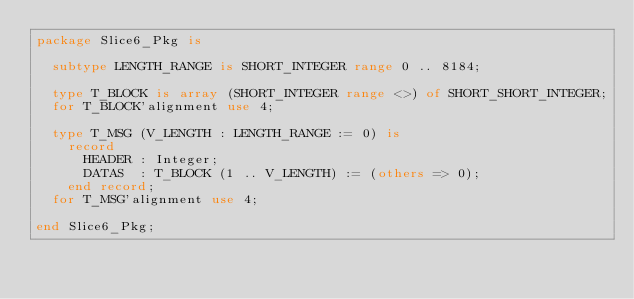<code> <loc_0><loc_0><loc_500><loc_500><_Ada_>package Slice6_Pkg is

  subtype LENGTH_RANGE is SHORT_INTEGER range 0 .. 8184;

  type T_BLOCK is array (SHORT_INTEGER range <>) of SHORT_SHORT_INTEGER;
  for T_BLOCK'alignment use 4;

  type T_MSG (V_LENGTH : LENGTH_RANGE := 0) is
    record
      HEADER : Integer;
      DATAS  : T_BLOCK (1 .. V_LENGTH) := (others => 0);
    end record;
  for T_MSG'alignment use 4;

end Slice6_Pkg;
</code> 